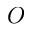Convert formula to latex. <formula><loc_0><loc_0><loc_500><loc_500>O</formula> 